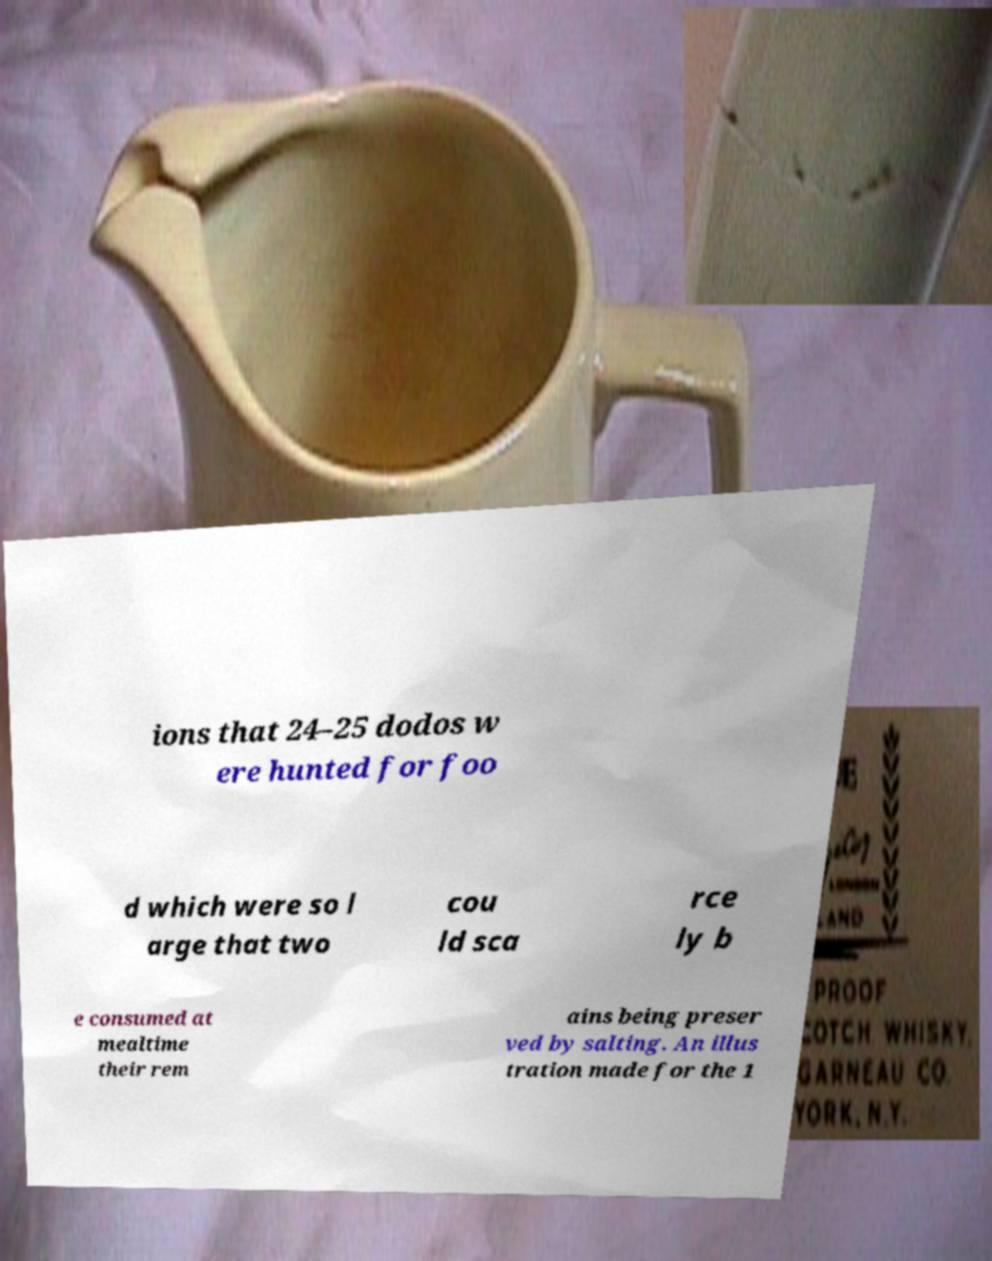What messages or text are displayed in this image? I need them in a readable, typed format. ions that 24–25 dodos w ere hunted for foo d which were so l arge that two cou ld sca rce ly b e consumed at mealtime their rem ains being preser ved by salting. An illus tration made for the 1 